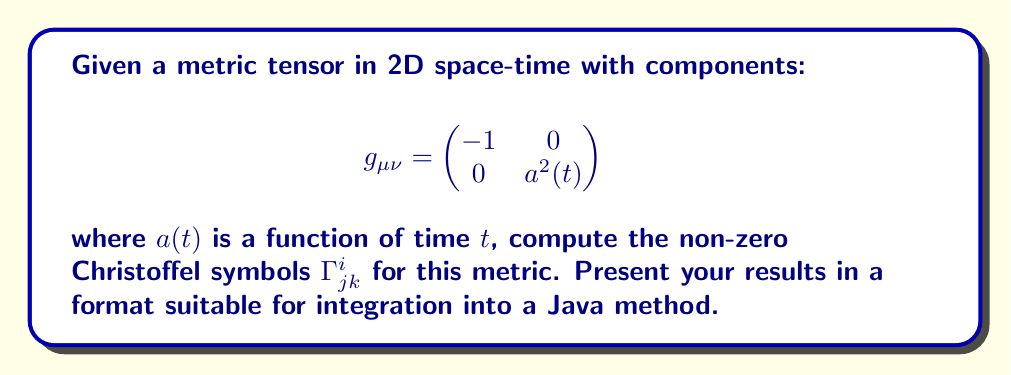Show me your answer to this math problem. To compute the Christoffel symbols, we'll follow these steps:

1. Recall the formula for Christoffel symbols:

   $$\Gamma^i_{jk} = \frac{1}{2}g^{im}(\partial_j g_{km} + \partial_k g_{jm} - \partial_m g_{jk})$$

2. Calculate the inverse metric tensor $g^{\mu\nu}$:

   $$g^{\mu\nu} = \begin{pmatrix}
   -1 & 0 \\
   0 & \frac{1}{a^2(t)}
   \end{pmatrix}$$

3. Calculate the partial derivatives of the metric tensor:

   $\partial_0 g_{11} = 0$
   $\partial_0 g_{00} = 0$
   $\partial_0 g_{01} = \partial_0 g_{10} = 0$
   $\partial_0 g_{11} = 2a(t)\dot{a}(t)$
   
   All other partial derivatives are zero.

4. Now, let's compute the non-zero Christoffel symbols:

   $\Gamma^0_{11} = \frac{1}{2}g^{00}(\partial_1 g_{10} + \partial_1 g_{10} - \partial_0 g_{11})$
                  $= -\frac{1}{2}(-2a(t)\dot{a}(t)) = a(t)\dot{a}(t)$

   $\Gamma^1_{01} = \Gamma^1_{10} = \frac{1}{2}g^{11}(\partial_0 g_{11}) = \frac{1}{2a^2(t)}(2a(t)\dot{a}(t)) = \frac{\dot{a}(t)}{a(t)}$

5. All other Christoffel symbols are zero.

6. To present these results in a format suitable for a Java method, we can return them as a 3D array or as a Map of String keys to Double values.
Answer: $$\Gamma^0_{11} = a(t)\dot{a}(t), \Gamma^1_{01} = \Gamma^1_{10} = \frac{\dot{a}(t)}{a(t)}$$ 